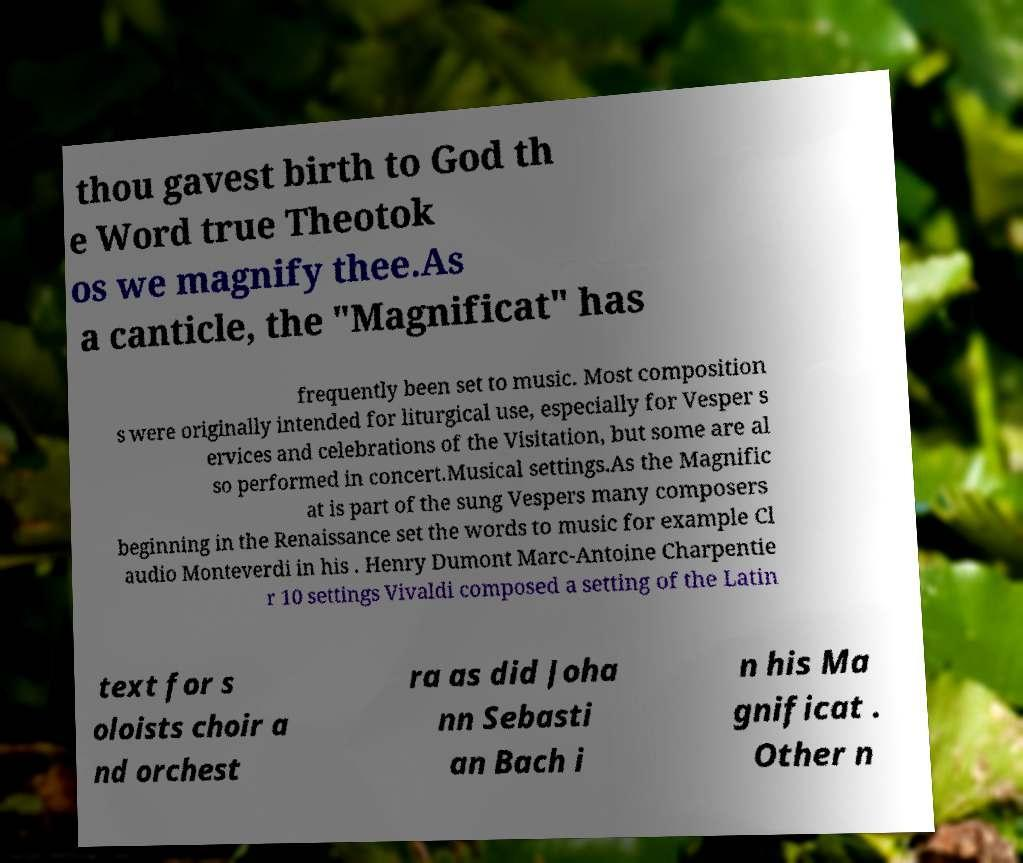Could you extract and type out the text from this image? thou gavest birth to God th e Word true Theotok os we magnify thee.As a canticle, the "Magnificat" has frequently been set to music. Most composition s were originally intended for liturgical use, especially for Vesper s ervices and celebrations of the Visitation, but some are al so performed in concert.Musical settings.As the Magnific at is part of the sung Vespers many composers beginning in the Renaissance set the words to music for example Cl audio Monteverdi in his . Henry Dumont Marc-Antoine Charpentie r 10 settings Vivaldi composed a setting of the Latin text for s oloists choir a nd orchest ra as did Joha nn Sebasti an Bach i n his Ma gnificat . Other n 